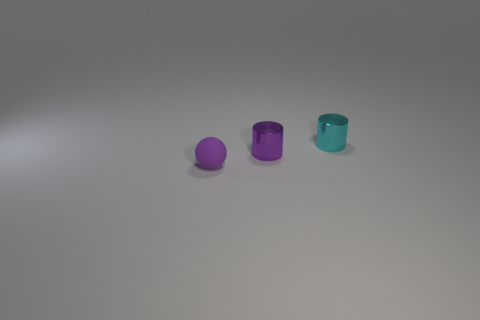There is a metallic thing that is in front of the tiny metal thing right of the purple shiny object; what is its shape?
Give a very brief answer. Cylinder. How many green objects are either cylinders or small matte spheres?
Your response must be concise. 0. What is the color of the sphere?
Make the answer very short. Purple. Is the cyan metallic object the same size as the purple metallic cylinder?
Offer a terse response. Yes. Is there any other thing that has the same shape as the purple rubber thing?
Your response must be concise. No. Does the tiny cyan thing have the same material as the tiny purple thing that is to the right of the purple rubber ball?
Your response must be concise. Yes. Does the small cylinder that is in front of the cyan metal cylinder have the same color as the tiny matte sphere?
Keep it short and to the point. Yes. What number of small objects are to the right of the small purple matte ball and in front of the tiny cyan metal cylinder?
Your response must be concise. 1. What number of other objects are the same material as the tiny purple ball?
Ensure brevity in your answer.  0. Do the small cylinder that is in front of the cyan object and the cyan cylinder have the same material?
Provide a short and direct response. Yes. 